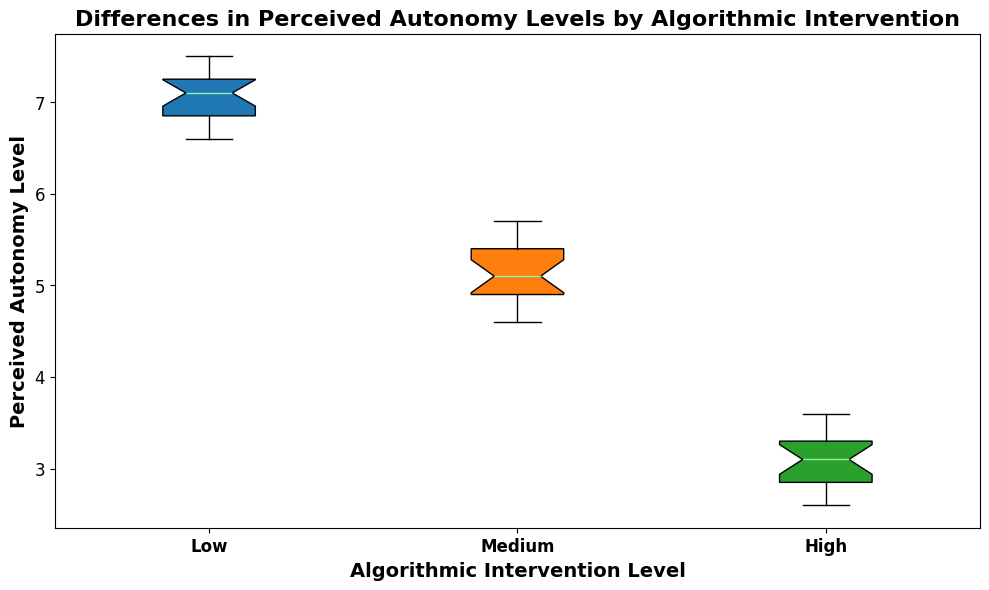What is the median perceived autonomy level for users with low algorithmic intervention? To find the median perceived autonomy level, look at the centerline inside the box plot for the 'Low' category. The median is visually represented by this line.
Answer: 7.1 Which algorithmic intervention level has the highest median perceived autonomy level? Compare the centerlines (medians) inside each box plot. The 'Low' category has the highest centerline compared to 'Medium' and 'High'.
Answer: Low Are the perceived autonomy levels for high algorithmic intervention more spread out than for low algorithmic intervention? Assess the interquartile range (IQR) by comparing the widths of the boxes. The 'High' category has a narrower box, indicating less spread in the data than the 'Low' category.
Answer: No What is the range of perceived autonomy levels for users with medium algorithmic intervention? The range is determined by subtracting the minimum value from the maximum value in the 'Medium' category. Examine the lowest and highest points (whiskers) in the 'Medium' category.
Answer: Approximately 4.6 to 5.7 Which algorithmic intervention level group has the smallest spread of perceived autonomy levels? The spread is visualized by the width of the boxplot. The 'High' category has the narrowest box, indicating the smallest spread.
Answer: High What is the difference between the median perceived autonomy levels of low and high algorithmic intervention groups? Find the centerlines (medians) for both 'Low' and 'High' groups, then subtract the median of 'High' from the median of 'Low'.
Answer: Approximately 4.0 How do the whiskers compare among the algorithmic intervention levels? Compare the lengths of the lines extending from the boxes (whiskers). The 'Low' category has longer whiskers, indicating a wider range of data compared to 'Medium' and 'High'.
Answer: Longer for Low category Which category has the lowest minimum perceived autonomy level, and what is its value? Look at the lowest point (whisker) for each category. The 'High' category has the lowest minimum compared to 'Low' and 'Medium'.
Answer: High, approximately 2.6 What is the interquartile range (IQR) for the high algorithmic intervention group? The IQR is the range between the 25th percentile and the 75th percentile. Observe the space between the bottom and top edges of the box for the 'High' category.
Answer: Approximately 0.5 